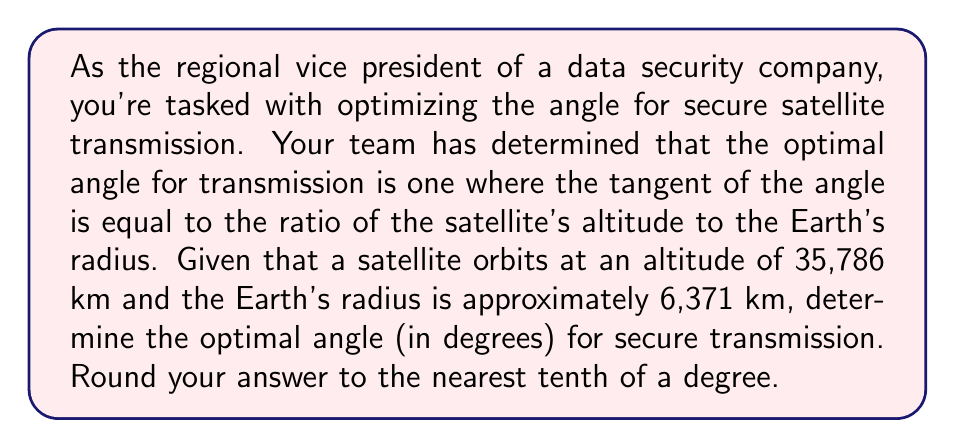Give your solution to this math problem. To solve this problem, we'll use trigonometry, specifically the tangent function. Let's approach this step-by-step:

1) First, let's define our variables:
   $h$ = satellite altitude = 35,786 km
   $r$ = Earth's radius = 6,371 km
   $\theta$ = optimal angle we're seeking

2) We're given that the tangent of the optimal angle is equal to the ratio of the satellite's altitude to the Earth's radius:

   $$\tan(\theta) = \frac{h}{r}$$

3) Let's substitute our known values:

   $$\tan(\theta) = \frac{35,786}{6,371}$$

4) Now we can calculate this ratio:

   $$\tan(\theta) = 5.6168$$

5) To find $\theta$, we need to use the inverse tangent (arctan) function:

   $$\theta = \arctan(5.6168)$$

6) Using a calculator or computer, we can evaluate this:

   $$\theta \approx 79.8949°$$

7) Rounding to the nearest tenth of a degree:

   $$\theta \approx 79.9°$$

This angle represents the optimal angle from the horizon to the satellite for secure transmission, maximizing signal strength while minimizing potential interception.
Answer: 79.9° 